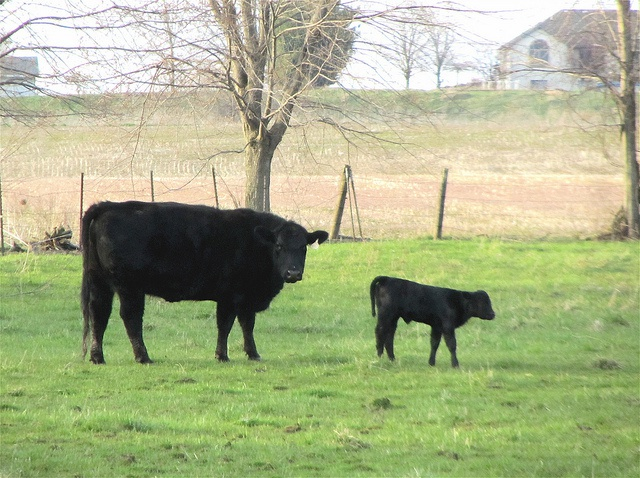Describe the objects in this image and their specific colors. I can see cow in gray, black, darkgreen, and olive tones and cow in gray, black, lightgreen, and darkgreen tones in this image. 